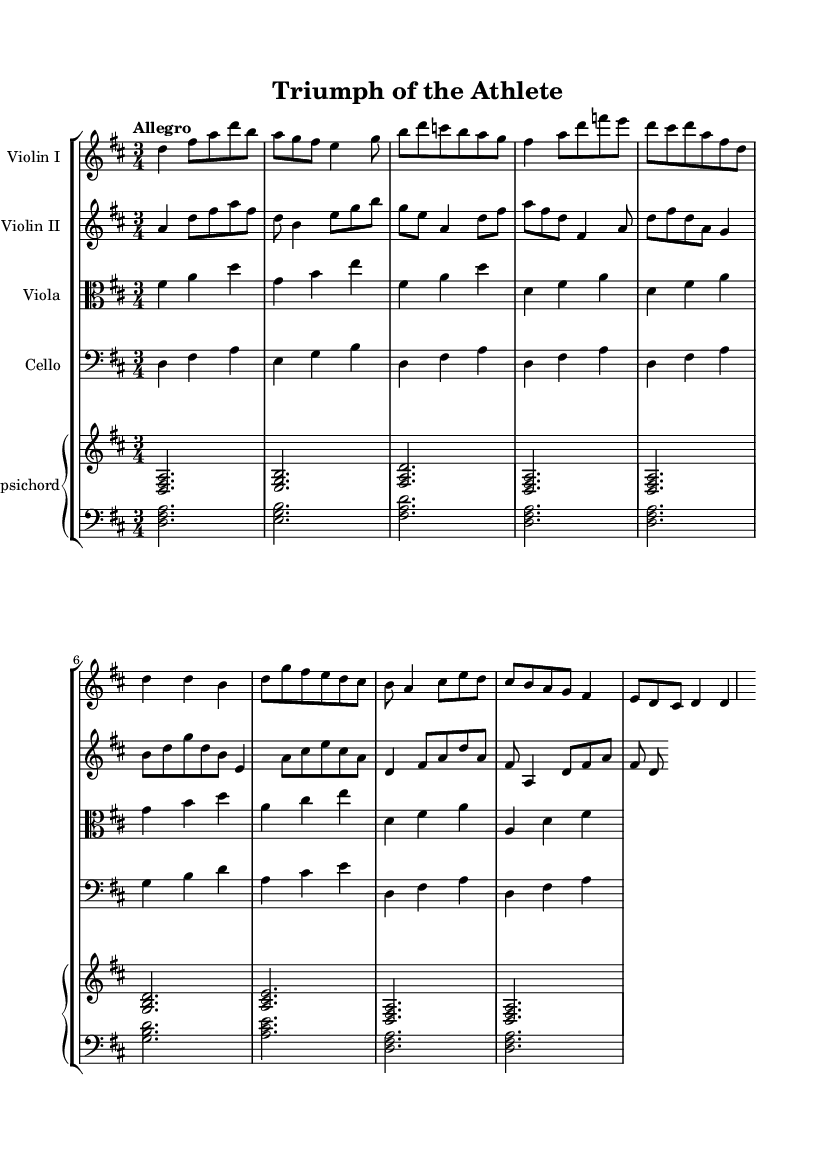What is the key signature of this music? The key signature is indicated at the beginning of the staff, showing two sharps, which corresponds to the key of D major.
Answer: D major What is the time signature of this piece? The time signature is found at the beginning of the music, showing three beats per measure, which is representative of a 3/4 time signature.
Answer: 3/4 What is the tempo marking of the piece? The tempo marking is provided at the beginning and indicates a lively pace, specifically marked as "Allegro."
Answer: Allegro How many different instruments are used in this score? By examining the score, there are four distinct staves which indicate different instruments: Violin I, Violin II, Viola, and Cello; along with a Harpsichord part that is divided into two staves. Thus, the total count is five instruments.
Answer: Five What is the instrumentation used in this piece? The instrumentation can be determined from the titles on each staff, which list the instruments: Violin I, Violin II, Viola, Cello, and Harpsichord.
Answer: Violin I, Violin II, Viola, Cello, Harpsichord What type of feeling or character does the music evoke, based on the tempo and rhythm? The Allegro marking combined with the 3/4 time signature suggests a lively and joyful character, often used in dance or celebratory contexts. Since the title refers to athletic feats, this further underscores a sense of movement and competition.
Answer: Lively/joyful 